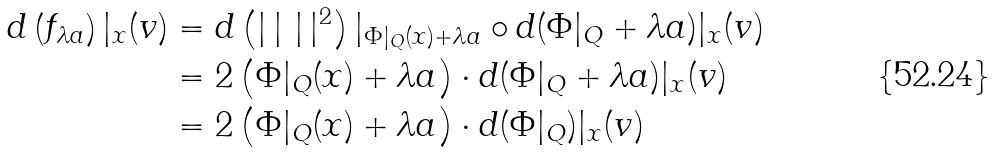<formula> <loc_0><loc_0><loc_500><loc_500>d \left ( f _ { \lambda a } \right ) | _ { x } ( v ) & = d \left ( | \, | \ | \, | ^ { 2 } \right ) | _ { \Phi | _ { Q } ( x ) + \lambda a } \circ d ( \Phi | _ { Q } + \lambda a ) | _ { x } ( v ) \\ & = 2 \left ( \Phi | _ { Q } ( x ) + \lambda a \right ) \cdot d ( \Phi | _ { Q } + \lambda a ) | _ { x } ( v ) \\ & = 2 \left ( \Phi | _ { Q } ( x ) + \lambda a \right ) \cdot d ( \Phi | _ { Q } ) | _ { x } ( v )</formula> 